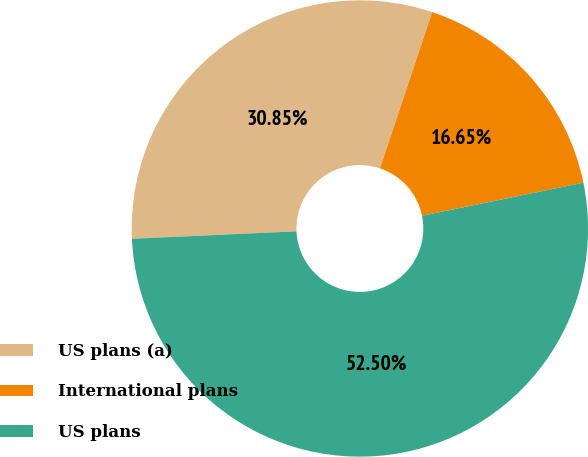Convert chart. <chart><loc_0><loc_0><loc_500><loc_500><pie_chart><fcel>US plans (a)<fcel>International plans<fcel>US plans<nl><fcel>30.85%<fcel>16.65%<fcel>52.5%<nl></chart> 